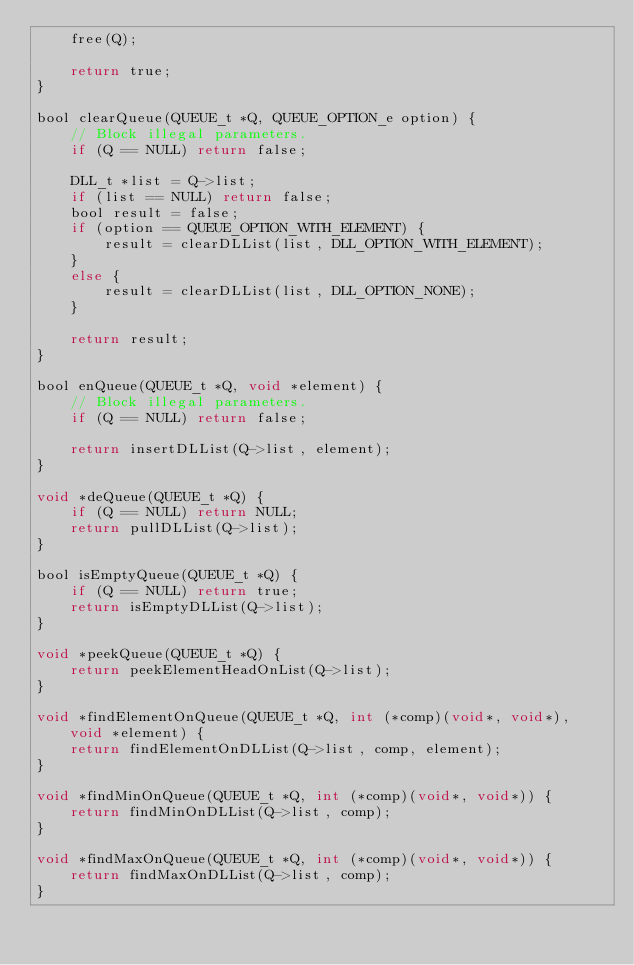Convert code to text. <code><loc_0><loc_0><loc_500><loc_500><_C_>    free(Q);
    
    return true;
}

bool clearQueue(QUEUE_t *Q, QUEUE_OPTION_e option) {
    // Block illegal parameters.
    if (Q == NULL) return false;
    
    DLL_t *list = Q->list;
    if (list == NULL) return false;
    bool result = false;
    if (option == QUEUE_OPTION_WITH_ELEMENT) {
        result = clearDLList(list, DLL_OPTION_WITH_ELEMENT);
    }
    else {
        result = clearDLList(list, DLL_OPTION_NONE);
    }
    
    return result;
}

bool enQueue(QUEUE_t *Q, void *element) {
    // Block illegal parameters.
    if (Q == NULL) return false;
    
    return insertDLList(Q->list, element);
}

void *deQueue(QUEUE_t *Q) {
    if (Q == NULL) return NULL;
    return pullDLList(Q->list);
}

bool isEmptyQueue(QUEUE_t *Q) {
    if (Q == NULL) return true;
    return isEmptyDLList(Q->list);
}

void *peekQueue(QUEUE_t *Q) {
    return peekElementHeadOnList(Q->list);
}

void *findElementOnQueue(QUEUE_t *Q, int (*comp)(void*, void*), void *element) {
    return findElementOnDLList(Q->list, comp, element);
}

void *findMinOnQueue(QUEUE_t *Q, int (*comp)(void*, void*)) {
    return findMinOnDLList(Q->list, comp);
}

void *findMaxOnQueue(QUEUE_t *Q, int (*comp)(void*, void*)) {
    return findMaxOnDLList(Q->list, comp);
}
</code> 